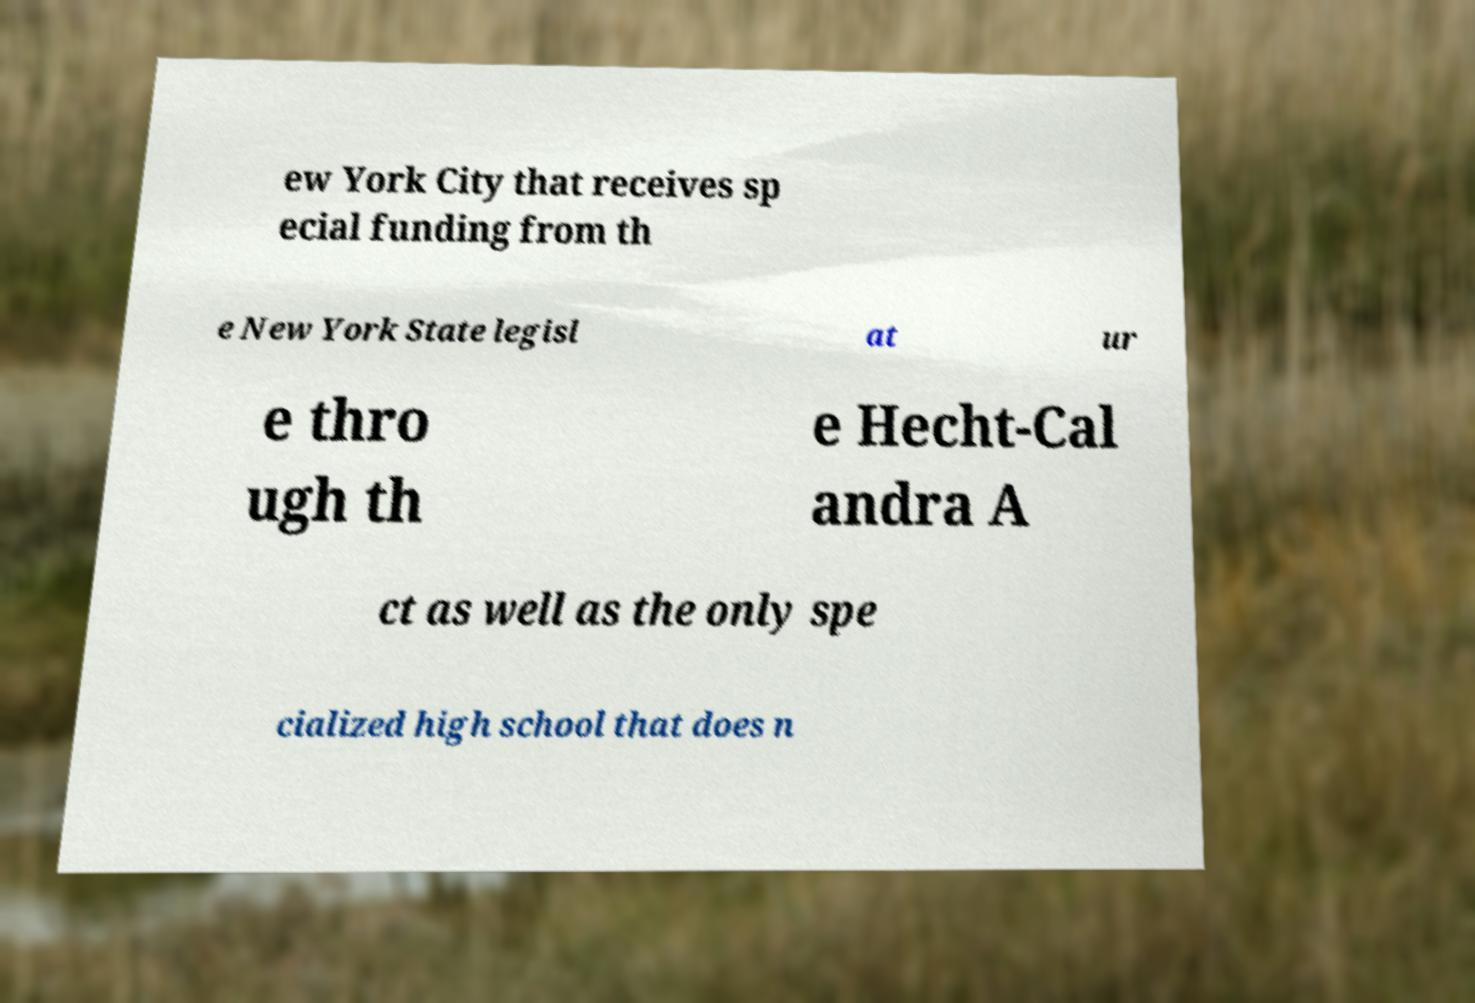Could you extract and type out the text from this image? ew York City that receives sp ecial funding from th e New York State legisl at ur e thro ugh th e Hecht-Cal andra A ct as well as the only spe cialized high school that does n 